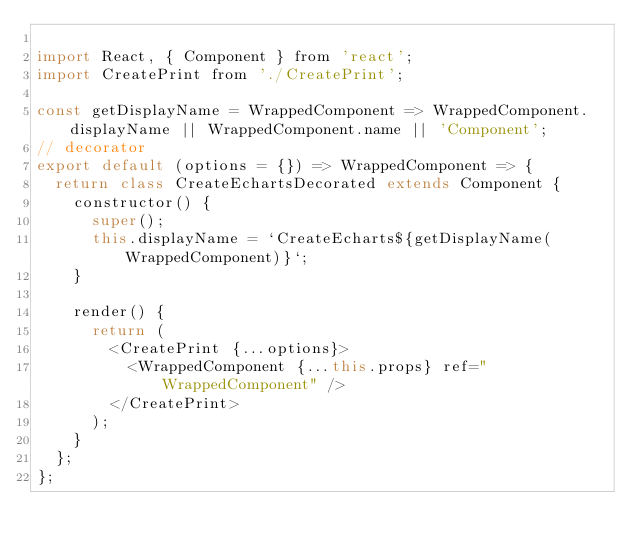<code> <loc_0><loc_0><loc_500><loc_500><_JavaScript_>
import React, { Component } from 'react';
import CreatePrint from './CreatePrint';

const getDisplayName = WrappedComponent => WrappedComponent.displayName || WrappedComponent.name || 'Component';
// decorator
export default (options = {}) => WrappedComponent => {
	return class CreateEchartsDecorated extends Component {
		constructor() {
			super();
			this.displayName = `CreateEcharts${getDisplayName(WrappedComponent)}`;
		}

		render() {
			return (
				<CreatePrint {...options}>
					<WrappedComponent {...this.props} ref="WrappedComponent" />
				</CreatePrint>
			);
		}
	};
};</code> 